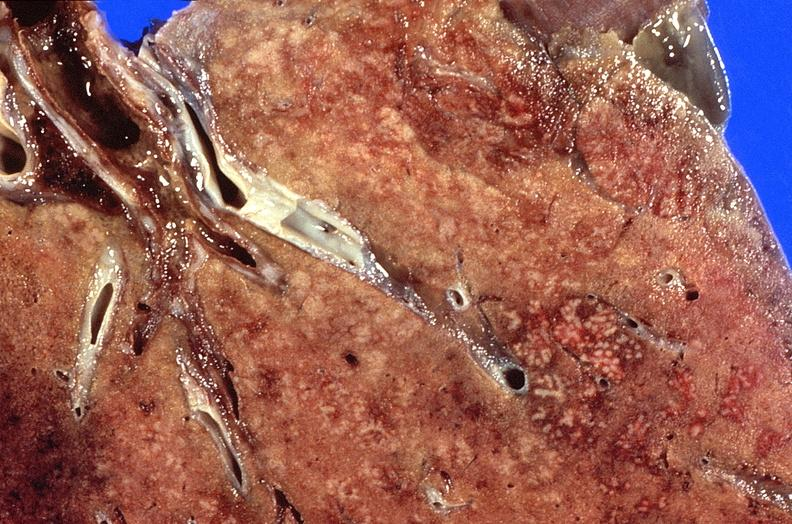what does this image show?
Answer the question using a single word or phrase. Lung 